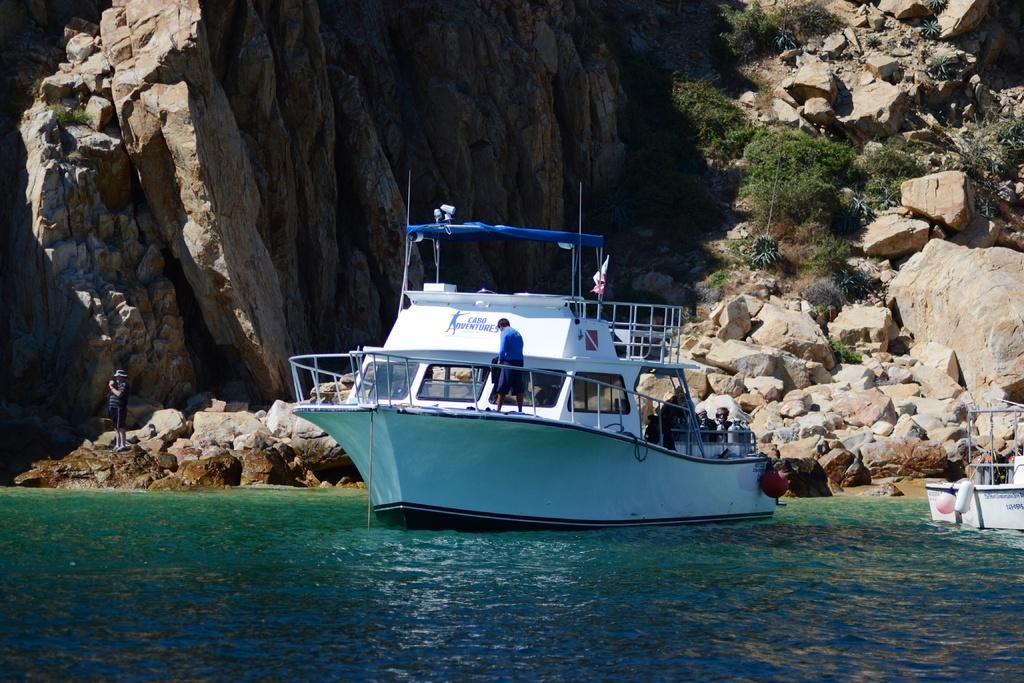Provide a one-sentence caption for the provided image. a boat with cabo adventures written on it sits in the ocean near a cliff side. 